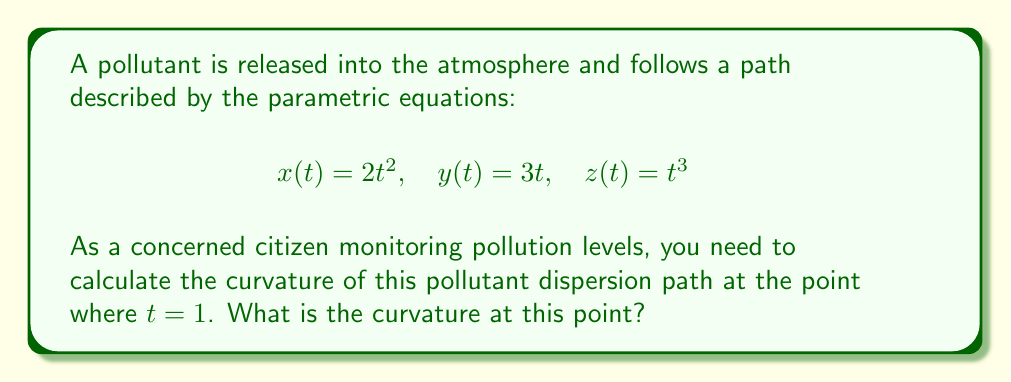What is the answer to this math problem? To calculate the curvature of the pollutant dispersion path, we'll follow these steps:

1) The curvature $\kappa$ for a space curve is given by:

   $$\kappa = \frac{|\mathbf{r}'(t) \times \mathbf{r}''(t)|}{|\mathbf{r}'(t)|^3}$$

2) First, we need to find $\mathbf{r}'(t)$ and $\mathbf{r}''(t)$:

   $$\mathbf{r}'(t) = (4t, 3, 3t^2)$$
   $$\mathbf{r}''(t) = (4, 0, 6t)$$

3) Now, we calculate $\mathbf{r}'(t) \times \mathbf{r}''(t)$:

   $$\mathbf{r}'(t) \times \mathbf{r}''(t) = (18t^2, 12t^3-12t, -12)$$

4) The magnitude of this cross product is:

   $$|\mathbf{r}'(t) \times \mathbf{r}''(t)| = \sqrt{(18t^2)^2 + (12t^3-12t)^2 + (-12)^2}$$

5) We also need $|\mathbf{r}'(t)|^3$:

   $$|\mathbf{r}'(t)|^3 = (16t^2 + 9 + 9t^4)^{3/2}$$

6) Now, we substitute $t = 1$ into these expressions:

   $$|\mathbf{r}'(1) \times \mathbf{r}''(1)| = \sqrt{18^2 + 0^2 + (-12)^2} = \sqrt{468} = 6\sqrt{13}$$
   $$|\mathbf{r}'(1)|^3 = (16 + 9 + 9)^{3/2} = 34^{3/2}$$

7) Finally, we calculate the curvature:

   $$\kappa = \frac{6\sqrt{13}}{34^{3/2}}$$
Answer: $\frac{6\sqrt{13}}{34^{3/2}}$ 